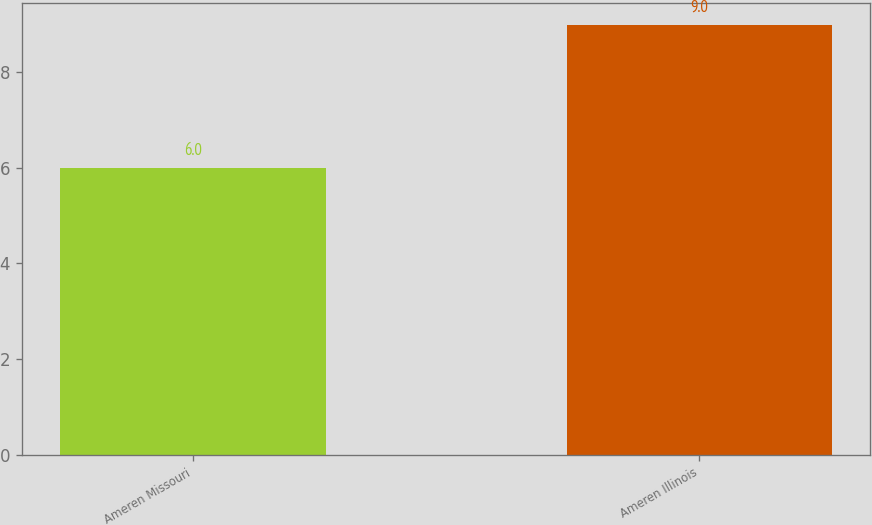<chart> <loc_0><loc_0><loc_500><loc_500><bar_chart><fcel>Ameren Missouri<fcel>Ameren Illinois<nl><fcel>6<fcel>9<nl></chart> 